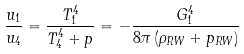Convert formula to latex. <formula><loc_0><loc_0><loc_500><loc_500>\frac { u _ { 1 } } { u _ { 4 } } = \frac { T _ { 1 } ^ { 4 } } { T _ { 4 } ^ { 4 } + p } = - \frac { G _ { 1 } ^ { 4 } } { 8 \pi \left ( \rho _ { R W } + p _ { R W } \right ) }</formula> 